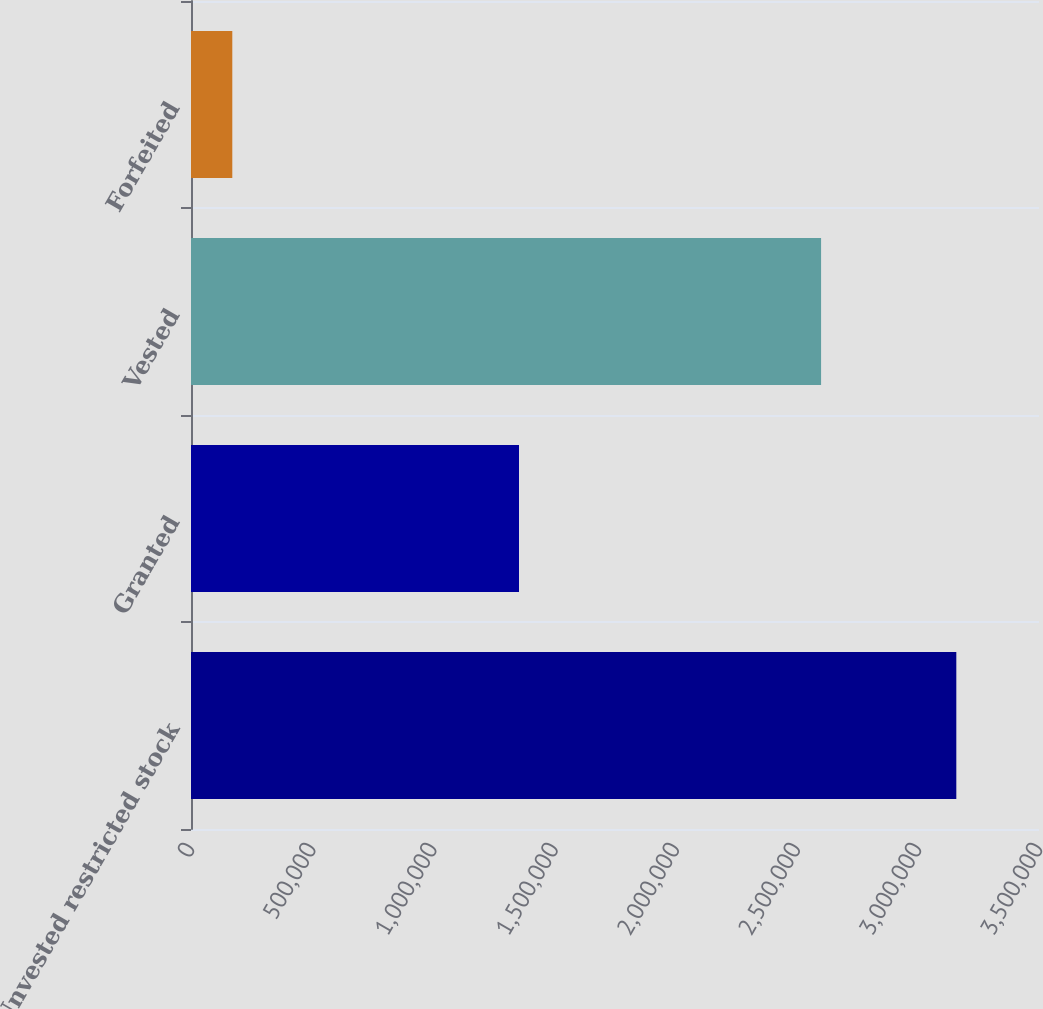Convert chart to OTSL. <chart><loc_0><loc_0><loc_500><loc_500><bar_chart><fcel>Unvested restricted stock<fcel>Granted<fcel>Vested<fcel>Forfeited<nl><fcel>3.15872e+06<fcel>1.3538e+06<fcel>2.60056e+06<fcel>170424<nl></chart> 